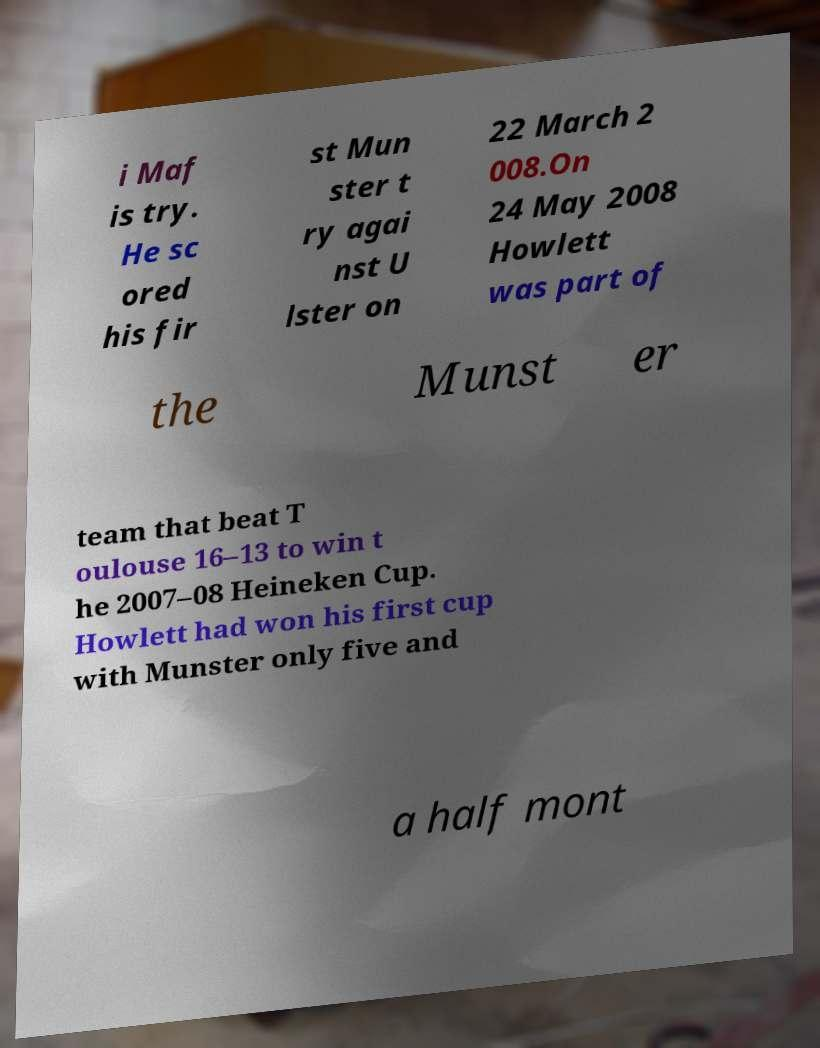Can you read and provide the text displayed in the image?This photo seems to have some interesting text. Can you extract and type it out for me? i Maf is try. He sc ored his fir st Mun ster t ry agai nst U lster on 22 March 2 008.On 24 May 2008 Howlett was part of the Munst er team that beat T oulouse 16–13 to win t he 2007–08 Heineken Cup. Howlett had won his first cup with Munster only five and a half mont 